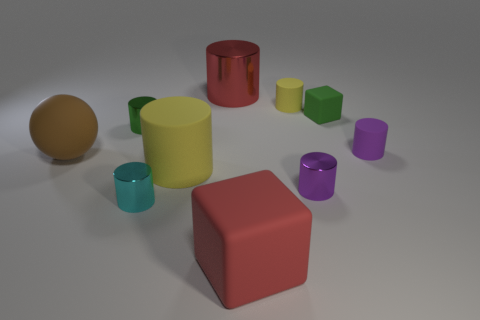Are there any other things that are the same size as the red cylinder?
Your answer should be compact. Yes. There is a green thing that is made of the same material as the brown ball; what size is it?
Provide a succinct answer. Small. There is a cube behind the tiny metallic cylinder that is on the right side of the large red rubber object; how many tiny purple metal cylinders are in front of it?
Provide a succinct answer. 1. There is another purple thing that is the same shape as the purple metallic object; what is it made of?
Provide a short and direct response. Rubber. What is the color of the big thing in front of the cyan metallic cylinder?
Keep it short and to the point. Red. Are the brown sphere and the red object behind the red matte cube made of the same material?
Your answer should be very brief. No. What is the small green cube made of?
Provide a short and direct response. Rubber. There is a large thing that is made of the same material as the small cyan object; what is its shape?
Your response must be concise. Cylinder. What number of other things are the same shape as the brown thing?
Offer a terse response. 0. There is a green cube; what number of yellow cylinders are behind it?
Provide a succinct answer. 1. 